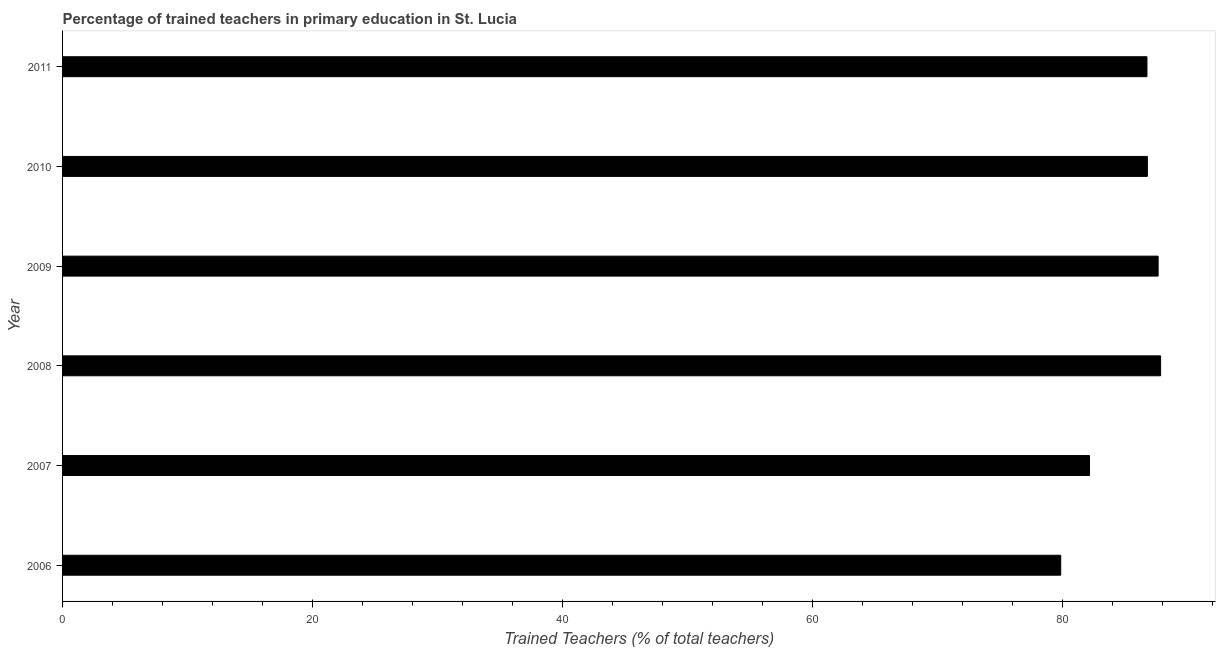Does the graph contain any zero values?
Your answer should be compact. No. What is the title of the graph?
Your answer should be very brief. Percentage of trained teachers in primary education in St. Lucia. What is the label or title of the X-axis?
Offer a terse response. Trained Teachers (% of total teachers). What is the percentage of trained teachers in 2008?
Make the answer very short. 87.83. Across all years, what is the maximum percentage of trained teachers?
Provide a succinct answer. 87.83. Across all years, what is the minimum percentage of trained teachers?
Give a very brief answer. 79.84. What is the sum of the percentage of trained teachers?
Offer a very short reply. 510.97. What is the difference between the percentage of trained teachers in 2007 and 2009?
Your answer should be very brief. -5.49. What is the average percentage of trained teachers per year?
Give a very brief answer. 85.16. What is the median percentage of trained teachers?
Offer a terse response. 86.76. In how many years, is the percentage of trained teachers greater than 52 %?
Provide a short and direct response. 6. What is the ratio of the percentage of trained teachers in 2007 to that in 2009?
Provide a short and direct response. 0.94. Is the percentage of trained teachers in 2008 less than that in 2011?
Ensure brevity in your answer.  No. Is the difference between the percentage of trained teachers in 2006 and 2009 greater than the difference between any two years?
Offer a terse response. No. What is the difference between the highest and the second highest percentage of trained teachers?
Ensure brevity in your answer.  0.2. Is the sum of the percentage of trained teachers in 2006 and 2007 greater than the maximum percentage of trained teachers across all years?
Offer a terse response. Yes. What is the difference between the highest and the lowest percentage of trained teachers?
Provide a succinct answer. 7.99. How many years are there in the graph?
Provide a succinct answer. 6. What is the difference between two consecutive major ticks on the X-axis?
Give a very brief answer. 20. What is the Trained Teachers (% of total teachers) of 2006?
Ensure brevity in your answer.  79.84. What is the Trained Teachers (% of total teachers) in 2007?
Offer a terse response. 82.15. What is the Trained Teachers (% of total teachers) of 2008?
Provide a succinct answer. 87.83. What is the Trained Teachers (% of total teachers) of 2009?
Your answer should be very brief. 87.64. What is the Trained Teachers (% of total teachers) in 2010?
Provide a succinct answer. 86.77. What is the Trained Teachers (% of total teachers) in 2011?
Your response must be concise. 86.74. What is the difference between the Trained Teachers (% of total teachers) in 2006 and 2007?
Your response must be concise. -2.3. What is the difference between the Trained Teachers (% of total teachers) in 2006 and 2008?
Your response must be concise. -7.99. What is the difference between the Trained Teachers (% of total teachers) in 2006 and 2009?
Your answer should be compact. -7.79. What is the difference between the Trained Teachers (% of total teachers) in 2006 and 2010?
Give a very brief answer. -6.93. What is the difference between the Trained Teachers (% of total teachers) in 2006 and 2011?
Ensure brevity in your answer.  -6.9. What is the difference between the Trained Teachers (% of total teachers) in 2007 and 2008?
Your answer should be compact. -5.69. What is the difference between the Trained Teachers (% of total teachers) in 2007 and 2009?
Offer a very short reply. -5.49. What is the difference between the Trained Teachers (% of total teachers) in 2007 and 2010?
Your answer should be very brief. -4.63. What is the difference between the Trained Teachers (% of total teachers) in 2007 and 2011?
Keep it short and to the point. -4.59. What is the difference between the Trained Teachers (% of total teachers) in 2008 and 2009?
Make the answer very short. 0.2. What is the difference between the Trained Teachers (% of total teachers) in 2008 and 2010?
Keep it short and to the point. 1.06. What is the difference between the Trained Teachers (% of total teachers) in 2008 and 2011?
Your answer should be compact. 1.09. What is the difference between the Trained Teachers (% of total teachers) in 2009 and 2010?
Your response must be concise. 0.86. What is the difference between the Trained Teachers (% of total teachers) in 2009 and 2011?
Give a very brief answer. 0.89. What is the difference between the Trained Teachers (% of total teachers) in 2010 and 2011?
Your answer should be compact. 0.03. What is the ratio of the Trained Teachers (% of total teachers) in 2006 to that in 2008?
Offer a very short reply. 0.91. What is the ratio of the Trained Teachers (% of total teachers) in 2006 to that in 2009?
Keep it short and to the point. 0.91. What is the ratio of the Trained Teachers (% of total teachers) in 2006 to that in 2010?
Offer a terse response. 0.92. What is the ratio of the Trained Teachers (% of total teachers) in 2006 to that in 2011?
Offer a very short reply. 0.92. What is the ratio of the Trained Teachers (% of total teachers) in 2007 to that in 2008?
Your answer should be compact. 0.94. What is the ratio of the Trained Teachers (% of total teachers) in 2007 to that in 2009?
Make the answer very short. 0.94. What is the ratio of the Trained Teachers (% of total teachers) in 2007 to that in 2010?
Your answer should be very brief. 0.95. What is the ratio of the Trained Teachers (% of total teachers) in 2007 to that in 2011?
Keep it short and to the point. 0.95. What is the ratio of the Trained Teachers (% of total teachers) in 2008 to that in 2009?
Offer a terse response. 1. What is the ratio of the Trained Teachers (% of total teachers) in 2008 to that in 2010?
Ensure brevity in your answer.  1.01. What is the ratio of the Trained Teachers (% of total teachers) in 2009 to that in 2010?
Provide a short and direct response. 1.01. What is the ratio of the Trained Teachers (% of total teachers) in 2009 to that in 2011?
Give a very brief answer. 1.01. What is the ratio of the Trained Teachers (% of total teachers) in 2010 to that in 2011?
Make the answer very short. 1. 